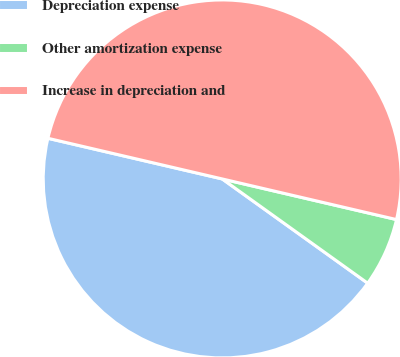Convert chart to OTSL. <chart><loc_0><loc_0><loc_500><loc_500><pie_chart><fcel>Depreciation expense<fcel>Other amortization expense<fcel>Increase in depreciation and<nl><fcel>43.75%<fcel>6.25%<fcel>50.0%<nl></chart> 